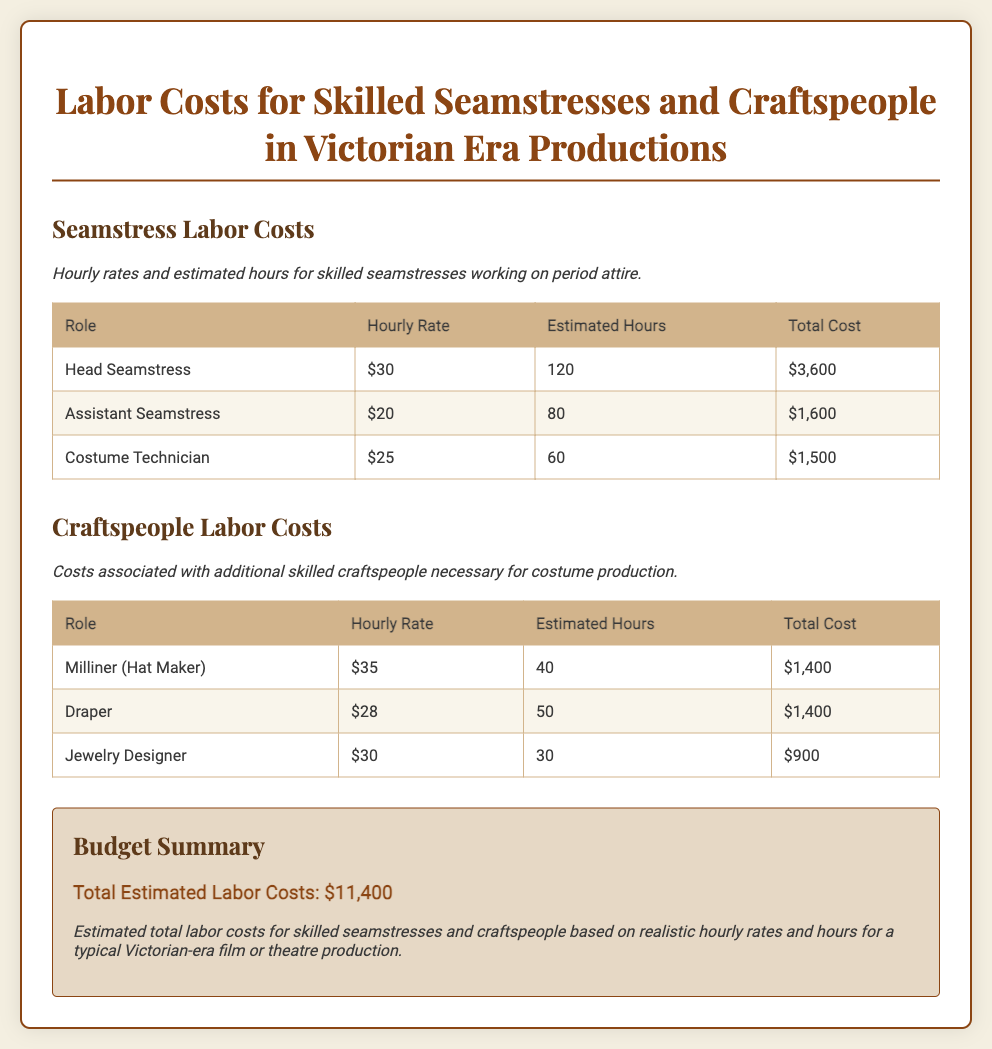what is the hourly rate for a Head Seamstress? The hourly rate for a Head Seamstress is specifically listed in the document.
Answer: $30 how many estimated hours does the Assistant Seamstress work? The document provides the estimated hours dedicated to the Assistant Seamstress role.
Answer: 80 what is the total labor cost for the Costume Technician? The total labor cost for the Costume Technician can be calculated based on the hourly rate and estimated hours mentioned in the document.
Answer: $1,500 what is the hourly rate for a Milliner? The document lists the hourly rate for a Milliner in the craftspeople section.
Answer: $35 who is responsible for making hats? The role responsible for making hats is mentioned in the craftspeople section of the document.
Answer: Milliner what is the total estimated labor cost for all skilled seamstresses? This total can be found by adding the individual labor costs of all seamstress roles in the document.
Answer: $6,700 what is the total estimated labor costs for skilled craftspeople? The total can be ascertained by summing up the labor costs listed for craftspeople in the document.
Answer: $3,700 what is the overall total estimated labor costs for the production? The document provides a summary of all labor costs combined for skilled seamstresses and craftspeople.
Answer: $11,400 how many estimated hours does the Jewelry Designer work? The document explicitly states the estimated hours for the Jewelry Designer role.
Answer: 30 what is the hourly rate for the Costume Technician? The hourly rate for the Costume Technician is included in the labor costs section.
Answer: $25 